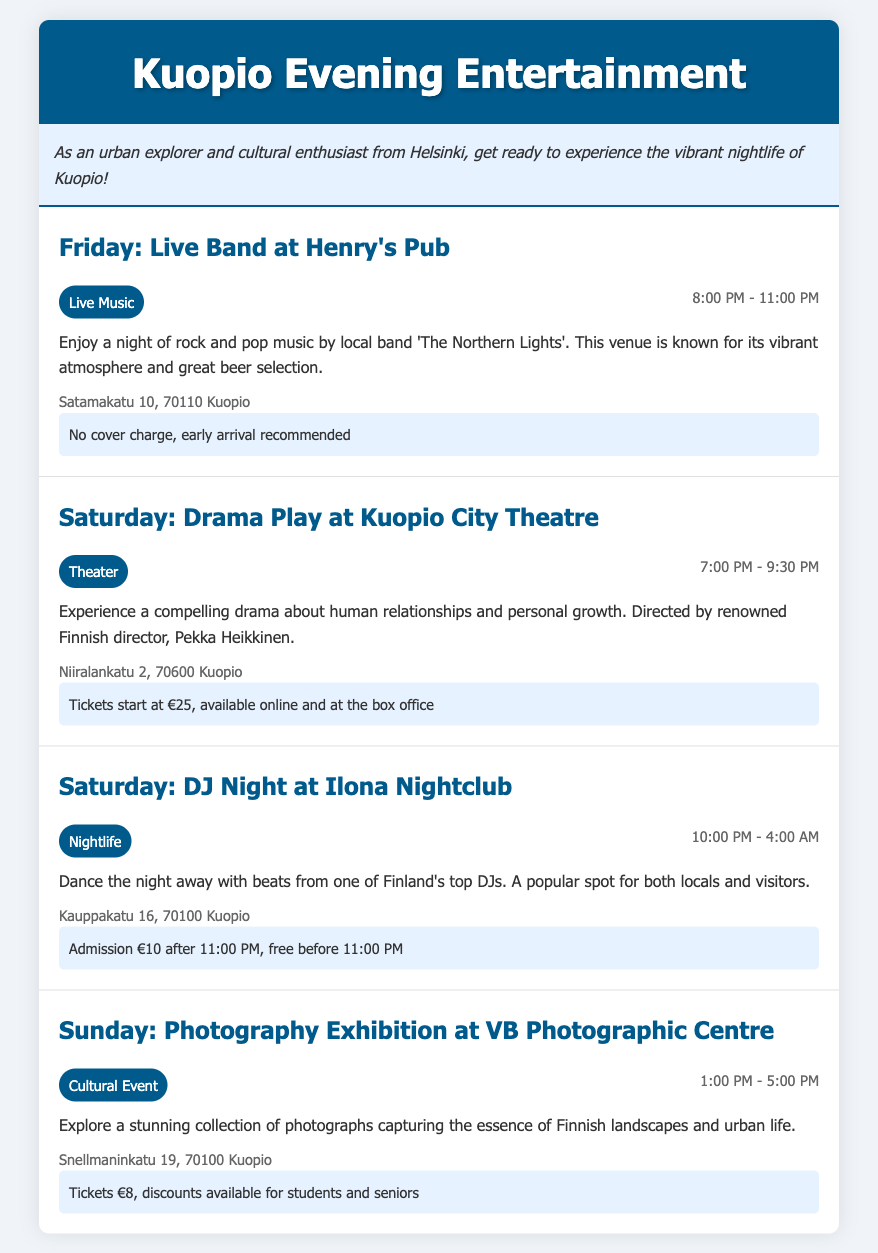What time does the live band at Henry's Pub start? The event details state that the live band starts at 8:00 PM.
Answer: 8:00 PM What is the address of the Kuopio City Theatre? The event description lists the address for Kuopio City Theatre as Niiralankatu 2, 70600 Kuopio.
Answer: Niiralankatu 2, 70600 Kuopio How much do tickets start at for the drama play? The ticket information indicates that tickets start at €25.
Answer: €25 What type of event is held at VB Photographic Centre on Sunday? The document specifies that the event at VB Photographic Centre is a Cultural Event.
Answer: Cultural Event What is the admission cost for Ilona Nightclub after 11:00 PM? The ticket information states that the admission cost after 11:00 PM is €10.
Answer: €10 What is the theme of the photography exhibition at VB Photographic Centre? The description mentions that the theme is about capturing the essence of Finnish landscapes and urban life.
Answer: Finnish landscapes and urban life Which day features a DJ Night at Ilona Nightclub? The schedule indicates that the DJ Night event takes place on Saturday.
Answer: Saturday What local band performs at Henry's Pub? The document names 'The Northern Lights' as the local band performing.
Answer: The Northern Lights 